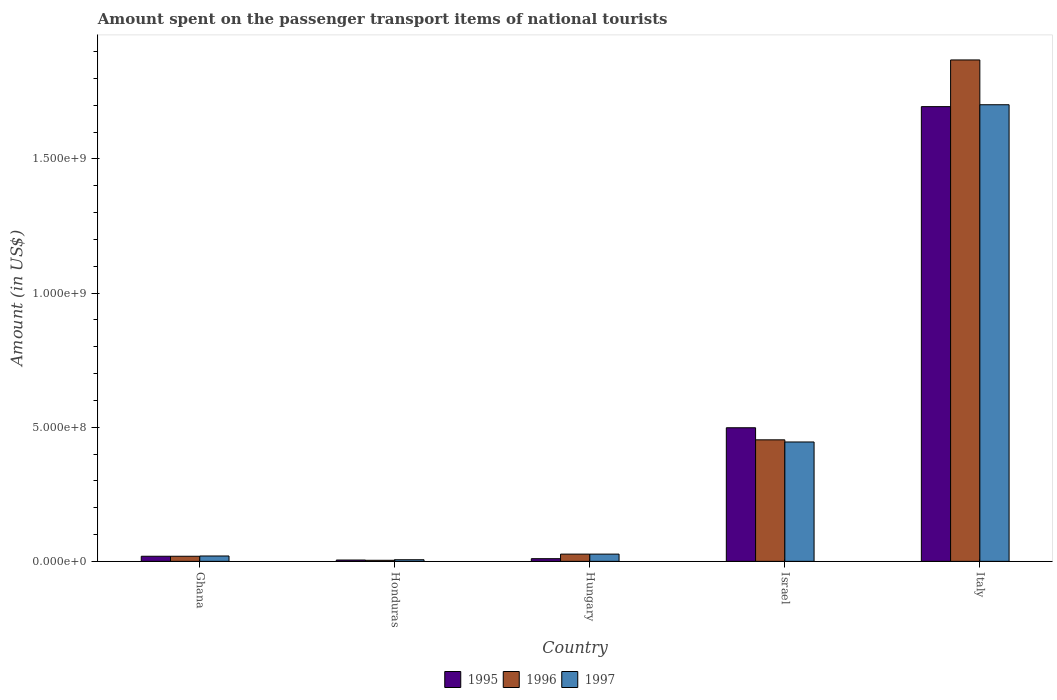How many different coloured bars are there?
Make the answer very short. 3. Are the number of bars on each tick of the X-axis equal?
Provide a succinct answer. Yes. How many bars are there on the 1st tick from the left?
Your response must be concise. 3. How many bars are there on the 3rd tick from the right?
Make the answer very short. 3. What is the label of the 5th group of bars from the left?
Make the answer very short. Italy. In how many cases, is the number of bars for a given country not equal to the number of legend labels?
Your answer should be very brief. 0. What is the amount spent on the passenger transport items of national tourists in 1995 in Israel?
Keep it short and to the point. 4.98e+08. Across all countries, what is the maximum amount spent on the passenger transport items of national tourists in 1997?
Provide a succinct answer. 1.70e+09. In which country was the amount spent on the passenger transport items of national tourists in 1995 maximum?
Ensure brevity in your answer.  Italy. In which country was the amount spent on the passenger transport items of national tourists in 1996 minimum?
Keep it short and to the point. Honduras. What is the total amount spent on the passenger transport items of national tourists in 1995 in the graph?
Give a very brief answer. 2.23e+09. What is the difference between the amount spent on the passenger transport items of national tourists in 1996 in Hungary and that in Italy?
Offer a terse response. -1.84e+09. What is the difference between the amount spent on the passenger transport items of national tourists in 1995 in Italy and the amount spent on the passenger transport items of national tourists in 1996 in Israel?
Offer a very short reply. 1.24e+09. What is the average amount spent on the passenger transport items of national tourists in 1995 per country?
Keep it short and to the point. 4.45e+08. What is the difference between the amount spent on the passenger transport items of national tourists of/in 1995 and amount spent on the passenger transport items of national tourists of/in 1996 in Hungary?
Ensure brevity in your answer.  -1.70e+07. What is the ratio of the amount spent on the passenger transport items of national tourists in 1997 in Ghana to that in Israel?
Provide a short and direct response. 0.04. What is the difference between the highest and the second highest amount spent on the passenger transport items of national tourists in 1995?
Offer a very short reply. 1.20e+09. What is the difference between the highest and the lowest amount spent on the passenger transport items of national tourists in 1996?
Provide a short and direct response. 1.86e+09. Is the sum of the amount spent on the passenger transport items of national tourists in 1995 in Honduras and Hungary greater than the maximum amount spent on the passenger transport items of national tourists in 1997 across all countries?
Make the answer very short. No. What does the 3rd bar from the left in Italy represents?
Offer a very short reply. 1997. How many bars are there?
Offer a very short reply. 15. What is the difference between two consecutive major ticks on the Y-axis?
Keep it short and to the point. 5.00e+08. Are the values on the major ticks of Y-axis written in scientific E-notation?
Your response must be concise. Yes. What is the title of the graph?
Your answer should be very brief. Amount spent on the passenger transport items of national tourists. What is the label or title of the Y-axis?
Make the answer very short. Amount (in US$). What is the Amount (in US$) in 1995 in Ghana?
Your answer should be very brief. 1.90e+07. What is the Amount (in US$) in 1996 in Ghana?
Your response must be concise. 1.90e+07. What is the Amount (in US$) of 1997 in Honduras?
Make the answer very short. 6.00e+06. What is the Amount (in US$) in 1995 in Hungary?
Your answer should be compact. 1.00e+07. What is the Amount (in US$) of 1996 in Hungary?
Give a very brief answer. 2.70e+07. What is the Amount (in US$) in 1997 in Hungary?
Your response must be concise. 2.70e+07. What is the Amount (in US$) of 1995 in Israel?
Your answer should be very brief. 4.98e+08. What is the Amount (in US$) in 1996 in Israel?
Ensure brevity in your answer.  4.53e+08. What is the Amount (in US$) in 1997 in Israel?
Make the answer very short. 4.45e+08. What is the Amount (in US$) of 1995 in Italy?
Keep it short and to the point. 1.70e+09. What is the Amount (in US$) of 1996 in Italy?
Keep it short and to the point. 1.87e+09. What is the Amount (in US$) of 1997 in Italy?
Ensure brevity in your answer.  1.70e+09. Across all countries, what is the maximum Amount (in US$) of 1995?
Make the answer very short. 1.70e+09. Across all countries, what is the maximum Amount (in US$) of 1996?
Offer a terse response. 1.87e+09. Across all countries, what is the maximum Amount (in US$) of 1997?
Give a very brief answer. 1.70e+09. Across all countries, what is the minimum Amount (in US$) of 1996?
Offer a very short reply. 4.00e+06. Across all countries, what is the minimum Amount (in US$) of 1997?
Provide a succinct answer. 6.00e+06. What is the total Amount (in US$) in 1995 in the graph?
Your answer should be very brief. 2.23e+09. What is the total Amount (in US$) of 1996 in the graph?
Your response must be concise. 2.37e+09. What is the total Amount (in US$) in 1997 in the graph?
Your response must be concise. 2.20e+09. What is the difference between the Amount (in US$) in 1995 in Ghana and that in Honduras?
Provide a succinct answer. 1.40e+07. What is the difference between the Amount (in US$) of 1996 in Ghana and that in Honduras?
Your answer should be compact. 1.50e+07. What is the difference between the Amount (in US$) of 1997 in Ghana and that in Honduras?
Ensure brevity in your answer.  1.40e+07. What is the difference between the Amount (in US$) of 1995 in Ghana and that in Hungary?
Make the answer very short. 9.00e+06. What is the difference between the Amount (in US$) of 1996 in Ghana and that in Hungary?
Provide a short and direct response. -8.00e+06. What is the difference between the Amount (in US$) in 1997 in Ghana and that in Hungary?
Give a very brief answer. -7.00e+06. What is the difference between the Amount (in US$) of 1995 in Ghana and that in Israel?
Offer a terse response. -4.79e+08. What is the difference between the Amount (in US$) of 1996 in Ghana and that in Israel?
Offer a terse response. -4.34e+08. What is the difference between the Amount (in US$) in 1997 in Ghana and that in Israel?
Offer a very short reply. -4.25e+08. What is the difference between the Amount (in US$) of 1995 in Ghana and that in Italy?
Offer a very short reply. -1.68e+09. What is the difference between the Amount (in US$) in 1996 in Ghana and that in Italy?
Keep it short and to the point. -1.85e+09. What is the difference between the Amount (in US$) in 1997 in Ghana and that in Italy?
Provide a succinct answer. -1.68e+09. What is the difference between the Amount (in US$) in 1995 in Honduras and that in Hungary?
Offer a very short reply. -5.00e+06. What is the difference between the Amount (in US$) in 1996 in Honduras and that in Hungary?
Your answer should be very brief. -2.30e+07. What is the difference between the Amount (in US$) in 1997 in Honduras and that in Hungary?
Provide a succinct answer. -2.10e+07. What is the difference between the Amount (in US$) of 1995 in Honduras and that in Israel?
Your answer should be very brief. -4.93e+08. What is the difference between the Amount (in US$) of 1996 in Honduras and that in Israel?
Make the answer very short. -4.49e+08. What is the difference between the Amount (in US$) of 1997 in Honduras and that in Israel?
Your answer should be compact. -4.39e+08. What is the difference between the Amount (in US$) in 1995 in Honduras and that in Italy?
Your answer should be very brief. -1.69e+09. What is the difference between the Amount (in US$) in 1996 in Honduras and that in Italy?
Ensure brevity in your answer.  -1.86e+09. What is the difference between the Amount (in US$) in 1997 in Honduras and that in Italy?
Make the answer very short. -1.70e+09. What is the difference between the Amount (in US$) in 1995 in Hungary and that in Israel?
Provide a succinct answer. -4.88e+08. What is the difference between the Amount (in US$) of 1996 in Hungary and that in Israel?
Ensure brevity in your answer.  -4.26e+08. What is the difference between the Amount (in US$) in 1997 in Hungary and that in Israel?
Your answer should be compact. -4.18e+08. What is the difference between the Amount (in US$) in 1995 in Hungary and that in Italy?
Offer a very short reply. -1.68e+09. What is the difference between the Amount (in US$) in 1996 in Hungary and that in Italy?
Make the answer very short. -1.84e+09. What is the difference between the Amount (in US$) in 1997 in Hungary and that in Italy?
Ensure brevity in your answer.  -1.68e+09. What is the difference between the Amount (in US$) in 1995 in Israel and that in Italy?
Give a very brief answer. -1.20e+09. What is the difference between the Amount (in US$) of 1996 in Israel and that in Italy?
Your answer should be very brief. -1.42e+09. What is the difference between the Amount (in US$) in 1997 in Israel and that in Italy?
Offer a very short reply. -1.26e+09. What is the difference between the Amount (in US$) in 1995 in Ghana and the Amount (in US$) in 1996 in Honduras?
Give a very brief answer. 1.50e+07. What is the difference between the Amount (in US$) of 1995 in Ghana and the Amount (in US$) of 1997 in Honduras?
Ensure brevity in your answer.  1.30e+07. What is the difference between the Amount (in US$) in 1996 in Ghana and the Amount (in US$) in 1997 in Honduras?
Your answer should be very brief. 1.30e+07. What is the difference between the Amount (in US$) in 1995 in Ghana and the Amount (in US$) in 1996 in Hungary?
Offer a very short reply. -8.00e+06. What is the difference between the Amount (in US$) in 1995 in Ghana and the Amount (in US$) in 1997 in Hungary?
Your answer should be very brief. -8.00e+06. What is the difference between the Amount (in US$) of 1996 in Ghana and the Amount (in US$) of 1997 in Hungary?
Your answer should be compact. -8.00e+06. What is the difference between the Amount (in US$) of 1995 in Ghana and the Amount (in US$) of 1996 in Israel?
Ensure brevity in your answer.  -4.34e+08. What is the difference between the Amount (in US$) in 1995 in Ghana and the Amount (in US$) in 1997 in Israel?
Ensure brevity in your answer.  -4.26e+08. What is the difference between the Amount (in US$) in 1996 in Ghana and the Amount (in US$) in 1997 in Israel?
Your answer should be very brief. -4.26e+08. What is the difference between the Amount (in US$) in 1995 in Ghana and the Amount (in US$) in 1996 in Italy?
Ensure brevity in your answer.  -1.85e+09. What is the difference between the Amount (in US$) of 1995 in Ghana and the Amount (in US$) of 1997 in Italy?
Offer a terse response. -1.68e+09. What is the difference between the Amount (in US$) of 1996 in Ghana and the Amount (in US$) of 1997 in Italy?
Provide a short and direct response. -1.68e+09. What is the difference between the Amount (in US$) in 1995 in Honduras and the Amount (in US$) in 1996 in Hungary?
Ensure brevity in your answer.  -2.20e+07. What is the difference between the Amount (in US$) of 1995 in Honduras and the Amount (in US$) of 1997 in Hungary?
Make the answer very short. -2.20e+07. What is the difference between the Amount (in US$) in 1996 in Honduras and the Amount (in US$) in 1997 in Hungary?
Offer a very short reply. -2.30e+07. What is the difference between the Amount (in US$) of 1995 in Honduras and the Amount (in US$) of 1996 in Israel?
Your response must be concise. -4.48e+08. What is the difference between the Amount (in US$) in 1995 in Honduras and the Amount (in US$) in 1997 in Israel?
Provide a short and direct response. -4.40e+08. What is the difference between the Amount (in US$) of 1996 in Honduras and the Amount (in US$) of 1997 in Israel?
Offer a terse response. -4.41e+08. What is the difference between the Amount (in US$) in 1995 in Honduras and the Amount (in US$) in 1996 in Italy?
Ensure brevity in your answer.  -1.86e+09. What is the difference between the Amount (in US$) of 1995 in Honduras and the Amount (in US$) of 1997 in Italy?
Make the answer very short. -1.70e+09. What is the difference between the Amount (in US$) in 1996 in Honduras and the Amount (in US$) in 1997 in Italy?
Your response must be concise. -1.70e+09. What is the difference between the Amount (in US$) in 1995 in Hungary and the Amount (in US$) in 1996 in Israel?
Offer a terse response. -4.43e+08. What is the difference between the Amount (in US$) in 1995 in Hungary and the Amount (in US$) in 1997 in Israel?
Make the answer very short. -4.35e+08. What is the difference between the Amount (in US$) of 1996 in Hungary and the Amount (in US$) of 1997 in Israel?
Give a very brief answer. -4.18e+08. What is the difference between the Amount (in US$) of 1995 in Hungary and the Amount (in US$) of 1996 in Italy?
Your response must be concise. -1.86e+09. What is the difference between the Amount (in US$) of 1995 in Hungary and the Amount (in US$) of 1997 in Italy?
Make the answer very short. -1.69e+09. What is the difference between the Amount (in US$) of 1996 in Hungary and the Amount (in US$) of 1997 in Italy?
Provide a succinct answer. -1.68e+09. What is the difference between the Amount (in US$) of 1995 in Israel and the Amount (in US$) of 1996 in Italy?
Offer a terse response. -1.37e+09. What is the difference between the Amount (in US$) in 1995 in Israel and the Amount (in US$) in 1997 in Italy?
Your answer should be very brief. -1.20e+09. What is the difference between the Amount (in US$) in 1996 in Israel and the Amount (in US$) in 1997 in Italy?
Ensure brevity in your answer.  -1.25e+09. What is the average Amount (in US$) in 1995 per country?
Your response must be concise. 4.45e+08. What is the average Amount (in US$) in 1996 per country?
Your response must be concise. 4.74e+08. What is the average Amount (in US$) in 1997 per country?
Give a very brief answer. 4.40e+08. What is the difference between the Amount (in US$) in 1995 and Amount (in US$) in 1996 in Ghana?
Give a very brief answer. 0. What is the difference between the Amount (in US$) in 1996 and Amount (in US$) in 1997 in Ghana?
Offer a terse response. -1.00e+06. What is the difference between the Amount (in US$) of 1995 and Amount (in US$) of 1996 in Honduras?
Keep it short and to the point. 1.00e+06. What is the difference between the Amount (in US$) in 1995 and Amount (in US$) in 1996 in Hungary?
Offer a very short reply. -1.70e+07. What is the difference between the Amount (in US$) in 1995 and Amount (in US$) in 1997 in Hungary?
Provide a short and direct response. -1.70e+07. What is the difference between the Amount (in US$) of 1996 and Amount (in US$) of 1997 in Hungary?
Your answer should be compact. 0. What is the difference between the Amount (in US$) of 1995 and Amount (in US$) of 1996 in Israel?
Provide a short and direct response. 4.50e+07. What is the difference between the Amount (in US$) of 1995 and Amount (in US$) of 1997 in Israel?
Your answer should be compact. 5.30e+07. What is the difference between the Amount (in US$) of 1995 and Amount (in US$) of 1996 in Italy?
Your answer should be compact. -1.74e+08. What is the difference between the Amount (in US$) of 1995 and Amount (in US$) of 1997 in Italy?
Provide a short and direct response. -7.00e+06. What is the difference between the Amount (in US$) of 1996 and Amount (in US$) of 1997 in Italy?
Your answer should be very brief. 1.67e+08. What is the ratio of the Amount (in US$) in 1995 in Ghana to that in Honduras?
Offer a very short reply. 3.8. What is the ratio of the Amount (in US$) of 1996 in Ghana to that in Honduras?
Keep it short and to the point. 4.75. What is the ratio of the Amount (in US$) in 1997 in Ghana to that in Honduras?
Your response must be concise. 3.33. What is the ratio of the Amount (in US$) of 1995 in Ghana to that in Hungary?
Your answer should be very brief. 1.9. What is the ratio of the Amount (in US$) in 1996 in Ghana to that in Hungary?
Offer a very short reply. 0.7. What is the ratio of the Amount (in US$) in 1997 in Ghana to that in Hungary?
Your answer should be very brief. 0.74. What is the ratio of the Amount (in US$) of 1995 in Ghana to that in Israel?
Offer a very short reply. 0.04. What is the ratio of the Amount (in US$) in 1996 in Ghana to that in Israel?
Offer a terse response. 0.04. What is the ratio of the Amount (in US$) in 1997 in Ghana to that in Israel?
Your answer should be very brief. 0.04. What is the ratio of the Amount (in US$) of 1995 in Ghana to that in Italy?
Your response must be concise. 0.01. What is the ratio of the Amount (in US$) of 1996 in Ghana to that in Italy?
Your answer should be compact. 0.01. What is the ratio of the Amount (in US$) in 1997 in Ghana to that in Italy?
Give a very brief answer. 0.01. What is the ratio of the Amount (in US$) of 1995 in Honduras to that in Hungary?
Offer a very short reply. 0.5. What is the ratio of the Amount (in US$) of 1996 in Honduras to that in Hungary?
Make the answer very short. 0.15. What is the ratio of the Amount (in US$) of 1997 in Honduras to that in Hungary?
Your answer should be very brief. 0.22. What is the ratio of the Amount (in US$) of 1995 in Honduras to that in Israel?
Your answer should be very brief. 0.01. What is the ratio of the Amount (in US$) in 1996 in Honduras to that in Israel?
Keep it short and to the point. 0.01. What is the ratio of the Amount (in US$) in 1997 in Honduras to that in Israel?
Make the answer very short. 0.01. What is the ratio of the Amount (in US$) of 1995 in Honduras to that in Italy?
Your answer should be very brief. 0. What is the ratio of the Amount (in US$) of 1996 in Honduras to that in Italy?
Make the answer very short. 0. What is the ratio of the Amount (in US$) of 1997 in Honduras to that in Italy?
Your answer should be compact. 0. What is the ratio of the Amount (in US$) in 1995 in Hungary to that in Israel?
Offer a terse response. 0.02. What is the ratio of the Amount (in US$) in 1996 in Hungary to that in Israel?
Give a very brief answer. 0.06. What is the ratio of the Amount (in US$) in 1997 in Hungary to that in Israel?
Ensure brevity in your answer.  0.06. What is the ratio of the Amount (in US$) in 1995 in Hungary to that in Italy?
Offer a terse response. 0.01. What is the ratio of the Amount (in US$) of 1996 in Hungary to that in Italy?
Ensure brevity in your answer.  0.01. What is the ratio of the Amount (in US$) in 1997 in Hungary to that in Italy?
Offer a very short reply. 0.02. What is the ratio of the Amount (in US$) in 1995 in Israel to that in Italy?
Make the answer very short. 0.29. What is the ratio of the Amount (in US$) in 1996 in Israel to that in Italy?
Ensure brevity in your answer.  0.24. What is the ratio of the Amount (in US$) in 1997 in Israel to that in Italy?
Your answer should be compact. 0.26. What is the difference between the highest and the second highest Amount (in US$) of 1995?
Provide a succinct answer. 1.20e+09. What is the difference between the highest and the second highest Amount (in US$) in 1996?
Your answer should be compact. 1.42e+09. What is the difference between the highest and the second highest Amount (in US$) in 1997?
Your answer should be very brief. 1.26e+09. What is the difference between the highest and the lowest Amount (in US$) of 1995?
Provide a succinct answer. 1.69e+09. What is the difference between the highest and the lowest Amount (in US$) in 1996?
Offer a terse response. 1.86e+09. What is the difference between the highest and the lowest Amount (in US$) of 1997?
Your answer should be very brief. 1.70e+09. 